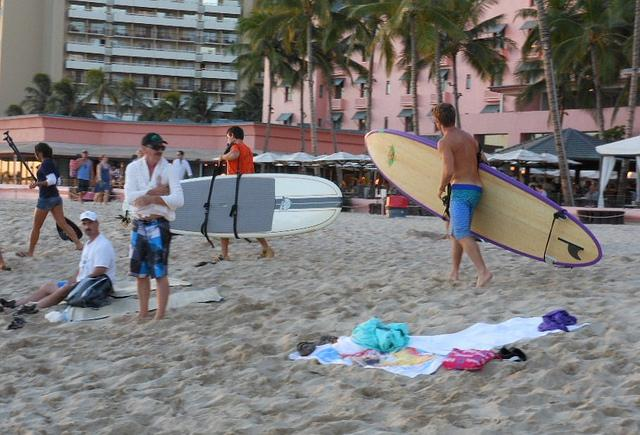What type of trees can be seen near the pink building?

Choices:
A) maple trees
B) pine trees
C) elm trees
D) palm trees palm trees 